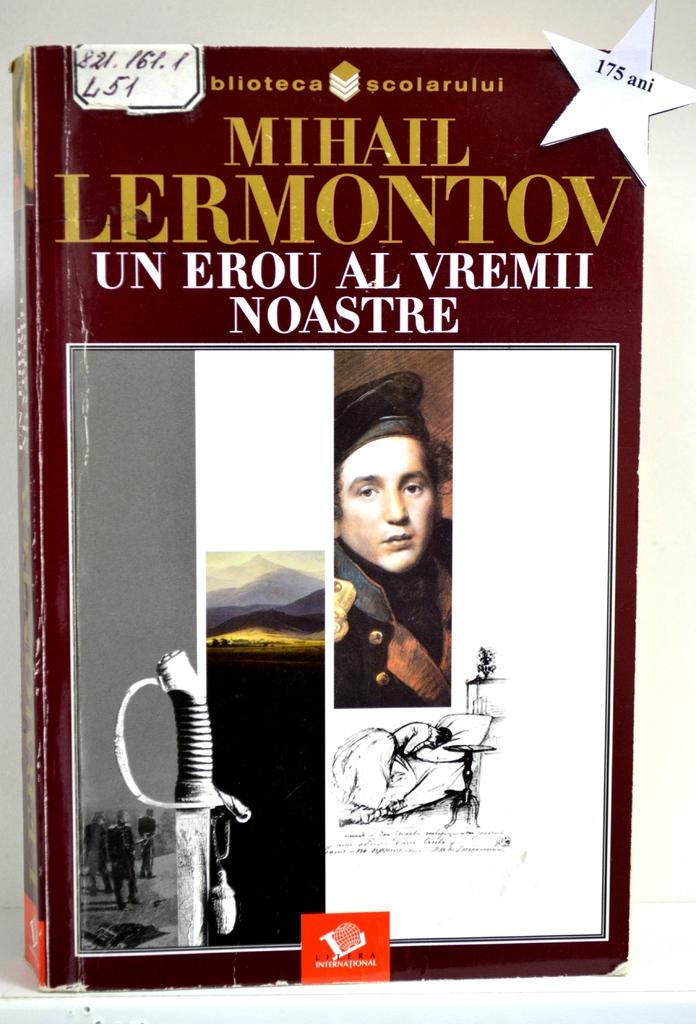What does it say inside the star?
Give a very brief answer. 175 ani. 